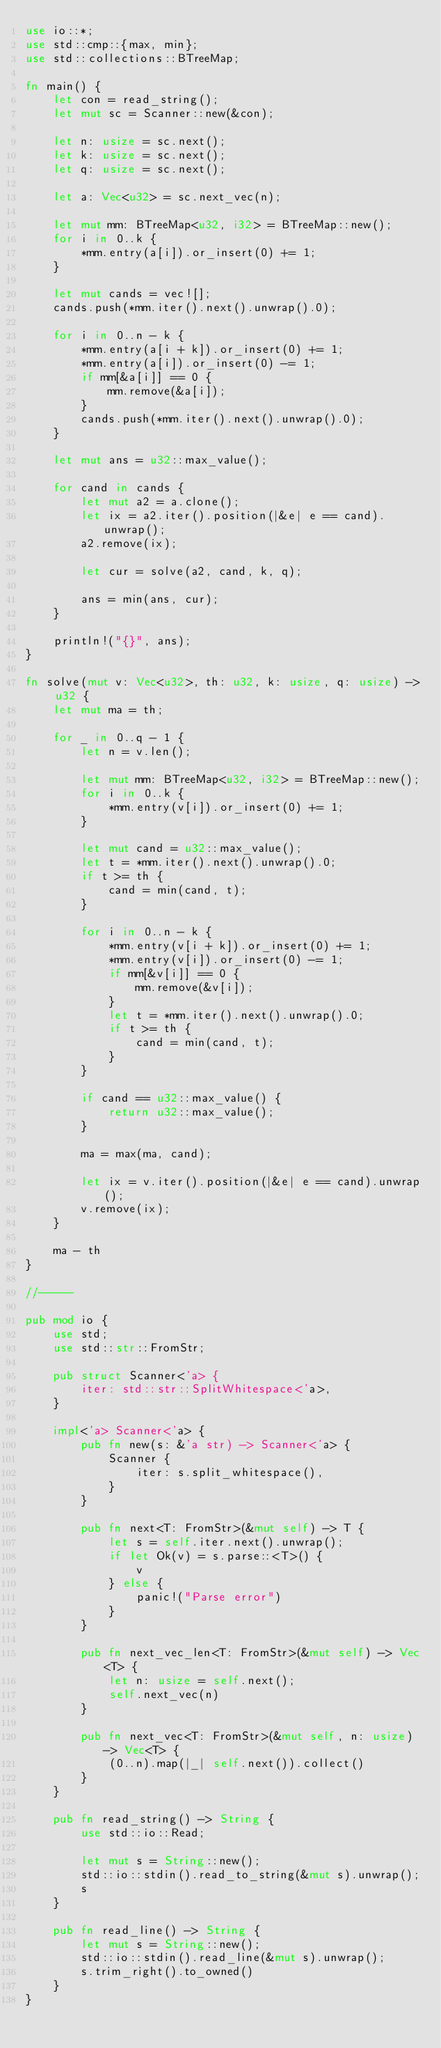Convert code to text. <code><loc_0><loc_0><loc_500><loc_500><_Rust_>use io::*;
use std::cmp::{max, min};
use std::collections::BTreeMap;

fn main() {
    let con = read_string();
    let mut sc = Scanner::new(&con);

    let n: usize = sc.next();
    let k: usize = sc.next();
    let q: usize = sc.next();

    let a: Vec<u32> = sc.next_vec(n);

    let mut mm: BTreeMap<u32, i32> = BTreeMap::new();
    for i in 0..k {
        *mm.entry(a[i]).or_insert(0) += 1;
    }

    let mut cands = vec![];
    cands.push(*mm.iter().next().unwrap().0);

    for i in 0..n - k {
        *mm.entry(a[i + k]).or_insert(0) += 1;
        *mm.entry(a[i]).or_insert(0) -= 1;
        if mm[&a[i]] == 0 {
            mm.remove(&a[i]);
        }
        cands.push(*mm.iter().next().unwrap().0);
    }

    let mut ans = u32::max_value();

    for cand in cands {
        let mut a2 = a.clone();
        let ix = a2.iter().position(|&e| e == cand).unwrap();
        a2.remove(ix);

        let cur = solve(a2, cand, k, q);

        ans = min(ans, cur);
    }

    println!("{}", ans);
}

fn solve(mut v: Vec<u32>, th: u32, k: usize, q: usize) -> u32 {
    let mut ma = th;

    for _ in 0..q - 1 {
        let n = v.len();

        let mut mm: BTreeMap<u32, i32> = BTreeMap::new();
        for i in 0..k {
            *mm.entry(v[i]).or_insert(0) += 1;
        }

        let mut cand = u32::max_value();
        let t = *mm.iter().next().unwrap().0;
        if t >= th {
            cand = min(cand, t);
        }

        for i in 0..n - k {
            *mm.entry(v[i + k]).or_insert(0) += 1;
            *mm.entry(v[i]).or_insert(0) -= 1;
            if mm[&v[i]] == 0 {
                mm.remove(&v[i]);
            }
            let t = *mm.iter().next().unwrap().0;
            if t >= th {
                cand = min(cand, t);
            }
        }

        if cand == u32::max_value() {
            return u32::max_value();
        }

        ma = max(ma, cand);

        let ix = v.iter().position(|&e| e == cand).unwrap();
        v.remove(ix);
    }

    ma - th
}

//-----

pub mod io {
    use std;
    use std::str::FromStr;

    pub struct Scanner<'a> {
        iter: std::str::SplitWhitespace<'a>,
    }

    impl<'a> Scanner<'a> {
        pub fn new(s: &'a str) -> Scanner<'a> {
            Scanner {
                iter: s.split_whitespace(),
            }
        }

        pub fn next<T: FromStr>(&mut self) -> T {
            let s = self.iter.next().unwrap();
            if let Ok(v) = s.parse::<T>() {
                v
            } else {
                panic!("Parse error")
            }
        }

        pub fn next_vec_len<T: FromStr>(&mut self) -> Vec<T> {
            let n: usize = self.next();
            self.next_vec(n)
        }

        pub fn next_vec<T: FromStr>(&mut self, n: usize) -> Vec<T> {
            (0..n).map(|_| self.next()).collect()
        }
    }

    pub fn read_string() -> String {
        use std::io::Read;

        let mut s = String::new();
        std::io::stdin().read_to_string(&mut s).unwrap();
        s
    }

    pub fn read_line() -> String {
        let mut s = String::new();
        std::io::stdin().read_line(&mut s).unwrap();
        s.trim_right().to_owned()
    }
}
</code> 